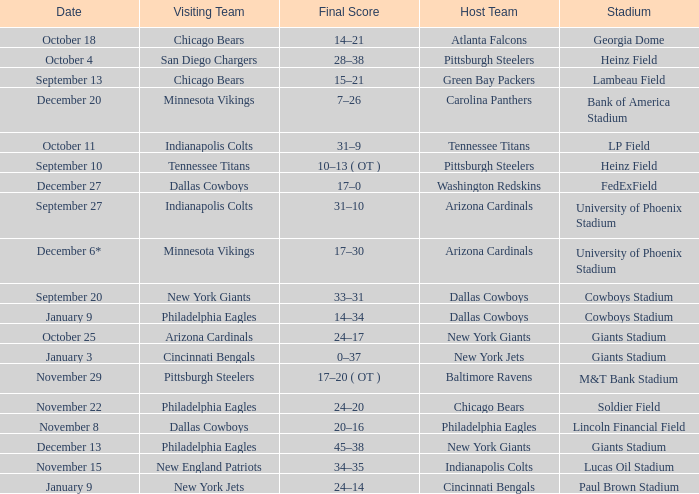Tell me the final score for january 9 for cincinnati bengals 24–14. 